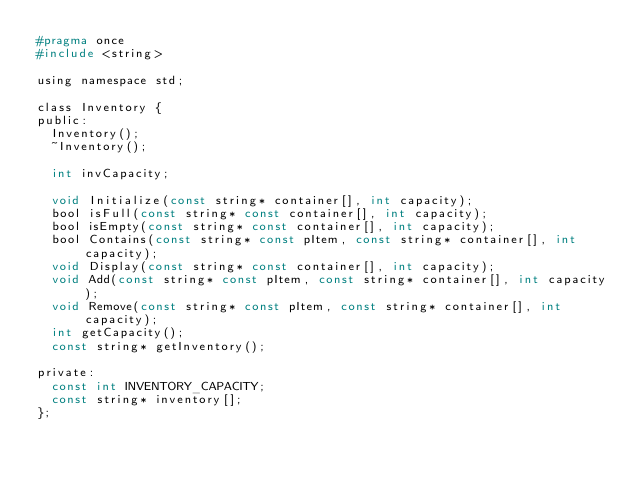<code> <loc_0><loc_0><loc_500><loc_500><_C_>#pragma once
#include <string>

using namespace std;

class Inventory {
public:
	Inventory();
	~Inventory();

	int invCapacity;

	void Initialize(const string* container[], int capacity);
	bool isFull(const string* const container[], int capacity);
	bool isEmpty(const string* const container[], int capacity);
	bool Contains(const string* const pItem, const string* container[], int capacity);
	void Display(const string* const container[], int capacity);
	void Add(const string* const pItem, const string* container[], int capacity);
	void Remove(const string* const pItem, const string* container[], int capacity);
	int getCapacity();
	const string* getInventory();

private:
	const int INVENTORY_CAPACITY;
	const string* inventory[];
};</code> 